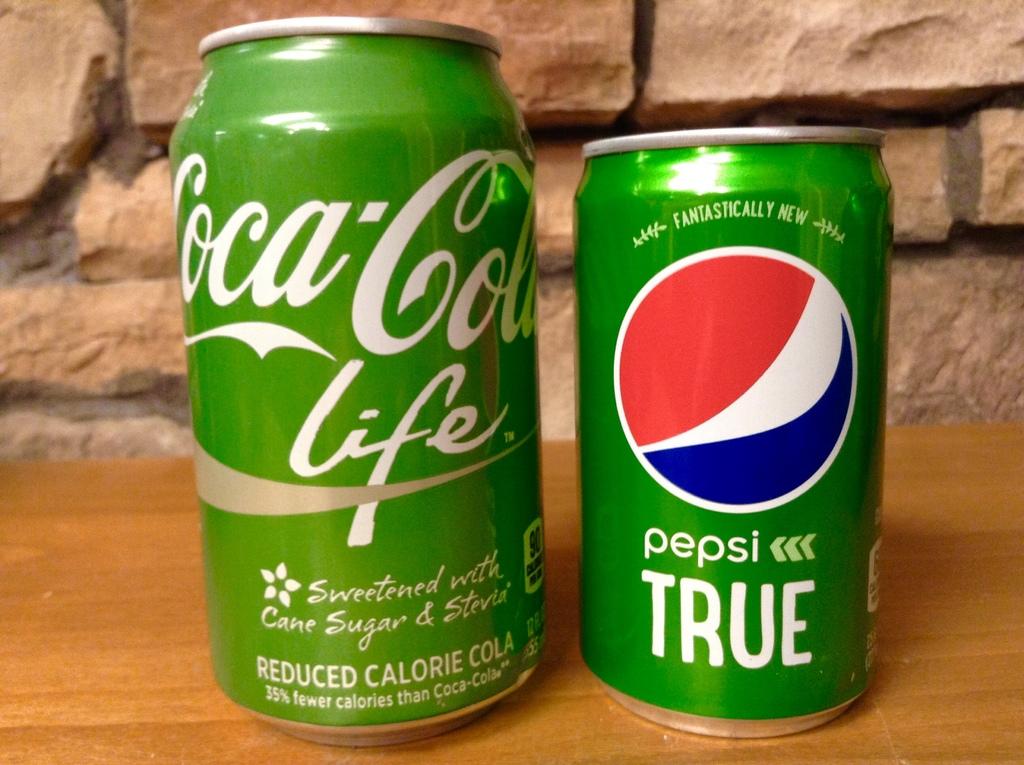Does the can on the left have cane sugar?
Make the answer very short. Yes. 